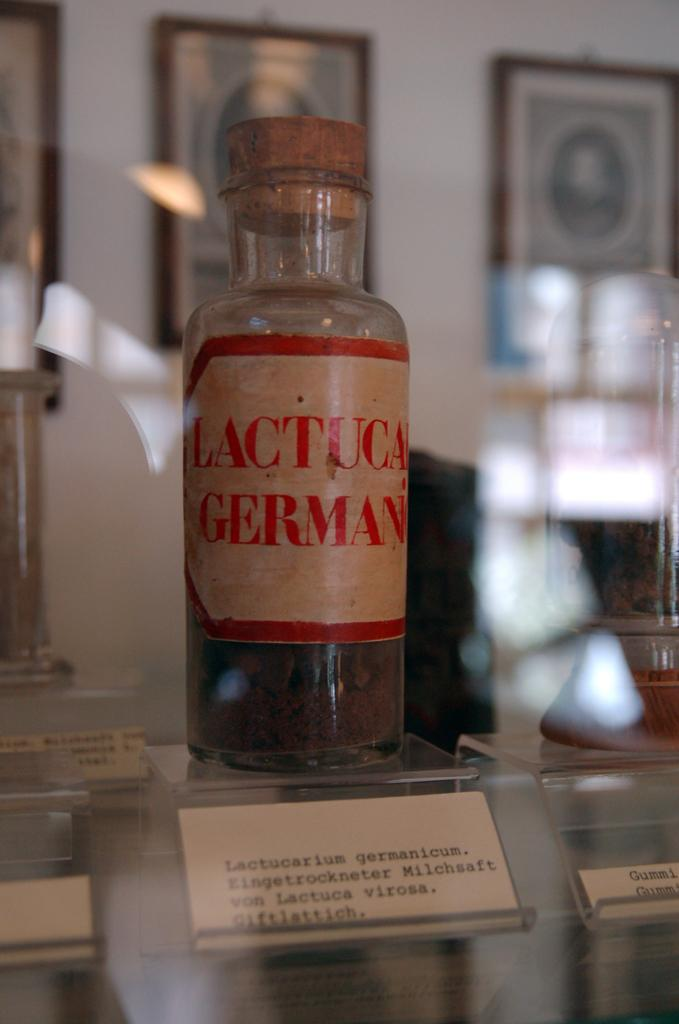What is the main object in the center of the image? There is a bottle in the center of the image. What is the name of the bottle? The bottle is named "German". What can be seen in the background of the image? There is a wall in the background of the image. What is on the wall in the image? The wall has photo frames on it. Can you tell me how many orders the sun has placed at the ocean in the image? There is no sun, orders, or ocean present in the image. 